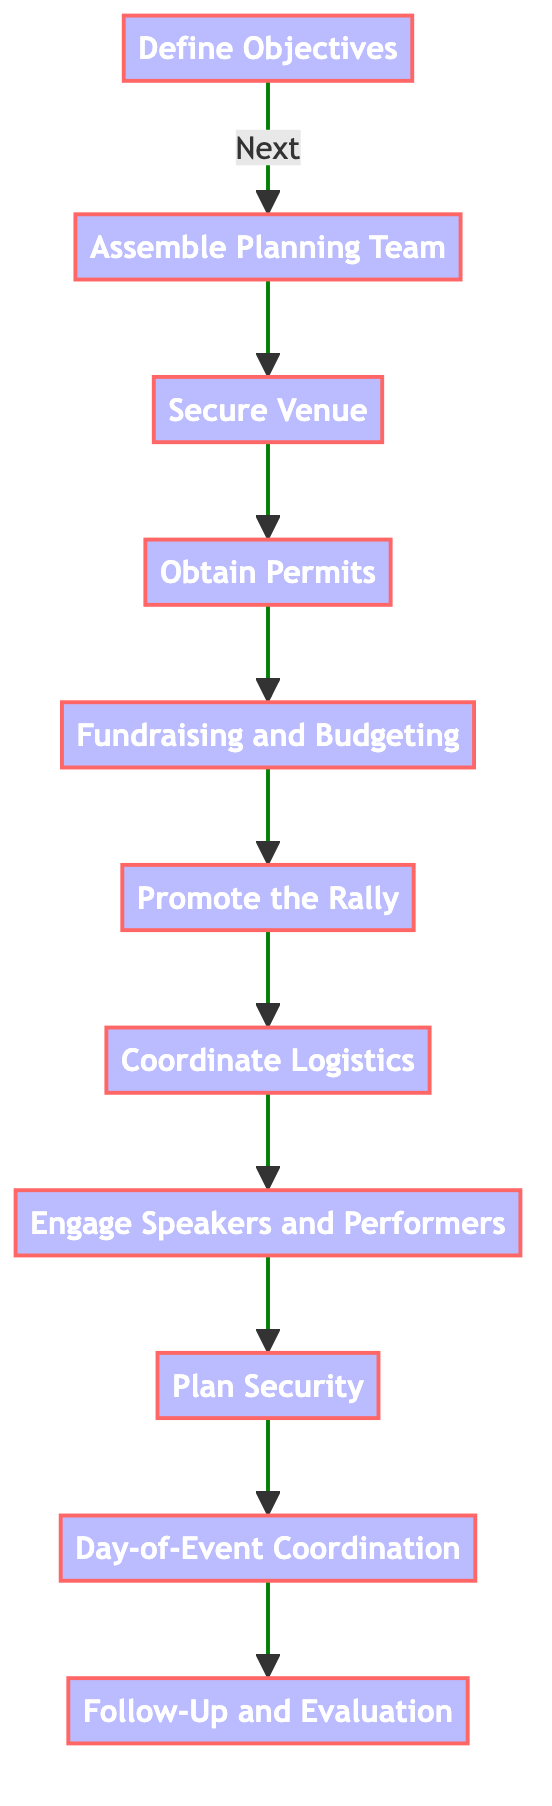What is the first step in organizing a political rally? The first step in the flowchart is "Define Objectives." This is indicated as the starting point of the flow process.
Answer: Define Objectives How many steps are shown in the flowchart? By counting each box from "Define Objectives" to "Follow-Up and Evaluation," there are a total of 11 steps in the diagram.
Answer: 11 Which step comes after "Secure Venue"? The step that follows "Secure Venue" is "Obtain Permits," as indicated by the arrow connecting these two nodes.
Answer: Obtain Permits What are the last two steps in this process? The last two steps shown in the diagram are "Day-of-Event Coordination" followed by "Follow-Up and Evaluation," as these are the final nodes in the flowchart sequence.
Answer: Day-of-Event Coordination, Follow-Up and Evaluation Which step involves promoting Mary Masanja’s involvement? The step that focuses on promoting Mary Masanja’s involvement is "Promote the Rally," where outreach efforts for the rally are planned.
Answer: Promote the Rally To organize security, which step should come just before it? The step that precedes "Plan Security" is "Engage Speakers and Performers," indicating the need for coordination of both speakers and security measures.
Answer: Engage Speakers and Performers What is the main activity in the fundraising and budgeting step? In the "Fundraising and Budgeting" step, the main activity is estimating costs and planning fundraising efforts to cover expenses for the rally.
Answer: Estimating costs and planning fundraising efforts How many steps involve coordinating or arranging? There are three steps that involve coordinating or arranging: "Assemble Planning Team," "Coordinate Logistics," and "Plan Security." This totals to three steps related to coordination.
Answer: 3 What does "Day-of-Event Coordination" ensure? "Day-of-Event Coordination" ensures that all team members know their roles and that the venue is appropriately managed during the event.
Answer: Roles are clear and venue is managed What comes at the end of the organizational steps? The last step after all organizational actions in the flowchart is "Follow-Up and Evaluation," which assesses the success of the rally and collects feedback.
Answer: Follow-Up and Evaluation 